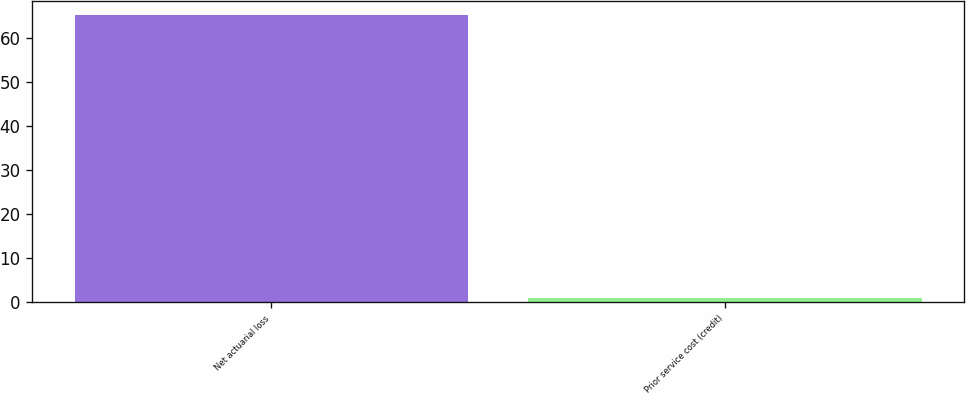Convert chart to OTSL. <chart><loc_0><loc_0><loc_500><loc_500><bar_chart><fcel>Net actuarial loss<fcel>Prior service cost (credit)<nl><fcel>65.1<fcel>1<nl></chart> 